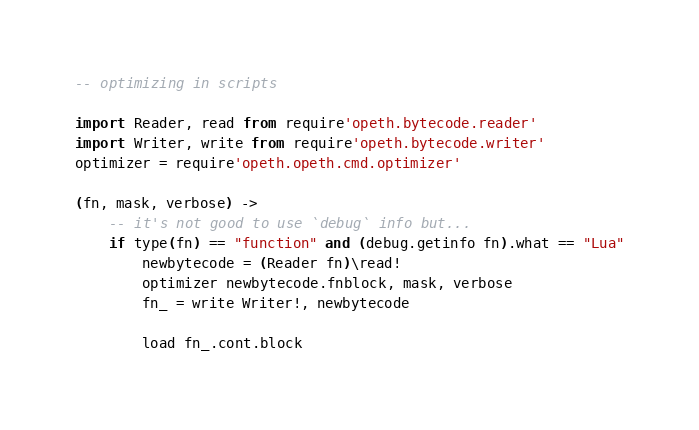<code> <loc_0><loc_0><loc_500><loc_500><_MoonScript_>-- optimizing in scripts

import Reader, read from require'opeth.bytecode.reader'
import Writer, write from require'opeth.bytecode.writer'
optimizer = require'opeth.opeth.cmd.optimizer'

(fn, mask, verbose) ->
	-- it's not good to use `debug` info but...
	if type(fn) == "function" and (debug.getinfo fn).what == "Lua"
		newbytecode = (Reader fn)\read!
		optimizer newbytecode.fnblock, mask, verbose
		fn_ = write Writer!, newbytecode

		load fn_.cont.block

</code> 